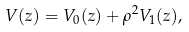<formula> <loc_0><loc_0><loc_500><loc_500>V ( z ) = V _ { 0 } ( z ) + \rho ^ { 2 } V _ { 1 } ( z ) ,</formula> 